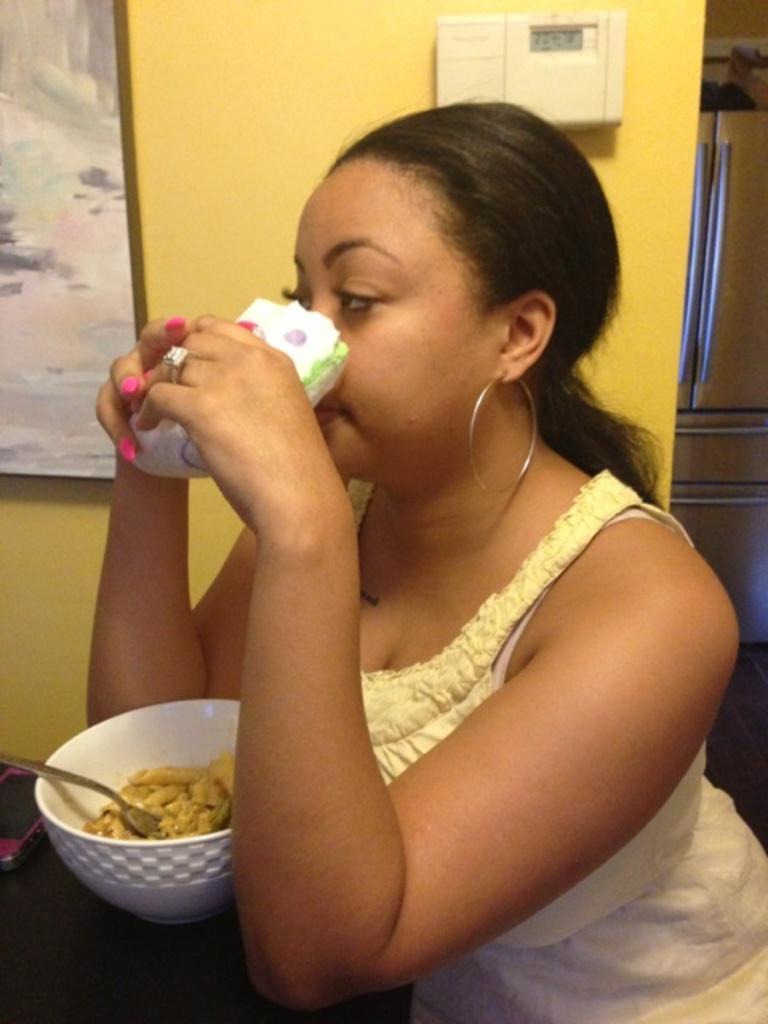Please provide a concise description of this image. In the center of the image we can see woman sitting at the table. On the table there is a mobile phone, bowl, spoon and food. In the background there is a wall and photo frame. 